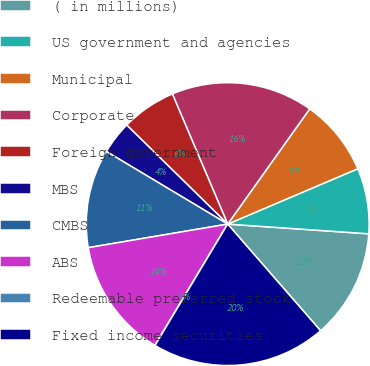Convert chart to OTSL. <chart><loc_0><loc_0><loc_500><loc_500><pie_chart><fcel>( in millions)<fcel>US government and agencies<fcel>Municipal<fcel>Corporate<fcel>Foreign government<fcel>MBS<fcel>CMBS<fcel>ABS<fcel>Redeemable preferred stock<fcel>Fixed income securities<nl><fcel>12.5%<fcel>7.5%<fcel>8.75%<fcel>16.24%<fcel>6.26%<fcel>3.76%<fcel>11.25%<fcel>13.74%<fcel>0.01%<fcel>19.99%<nl></chart> 